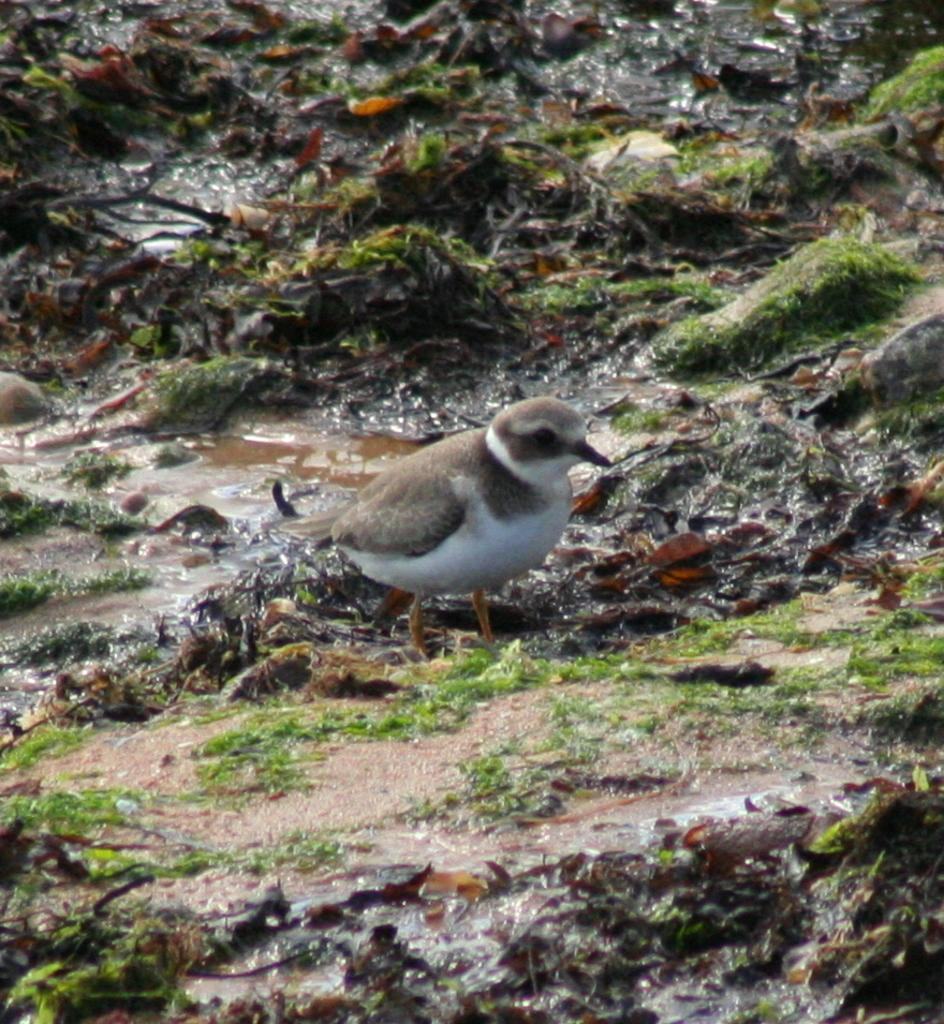What is the main subject in the center of the image? There is a bird in the center of the image. Where is the bird located? The bird is on the ground. What type of vegetation can be seen in the image? There is grass visible in the image. What other elements can be seen on the ground? There are stones visible in the image. What else is present in the image besides the bird, grass, and stones? There is water visible in the image. What type of spark can be seen coming from the bird's beak in the image? There is no spark coming from the bird's beak in the image. 